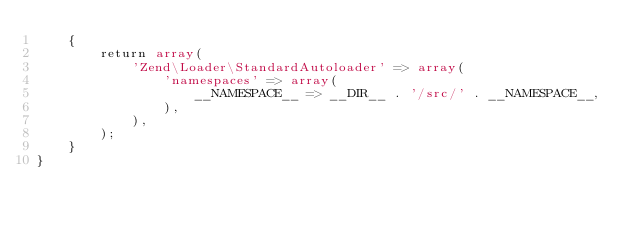<code> <loc_0><loc_0><loc_500><loc_500><_PHP_>    {
        return array(
            'Zend\Loader\StandardAutoloader' => array(
                'namespaces' => array(
                    __NAMESPACE__ => __DIR__ . '/src/' . __NAMESPACE__,
                ),
            ),
        );
    }
}
</code> 